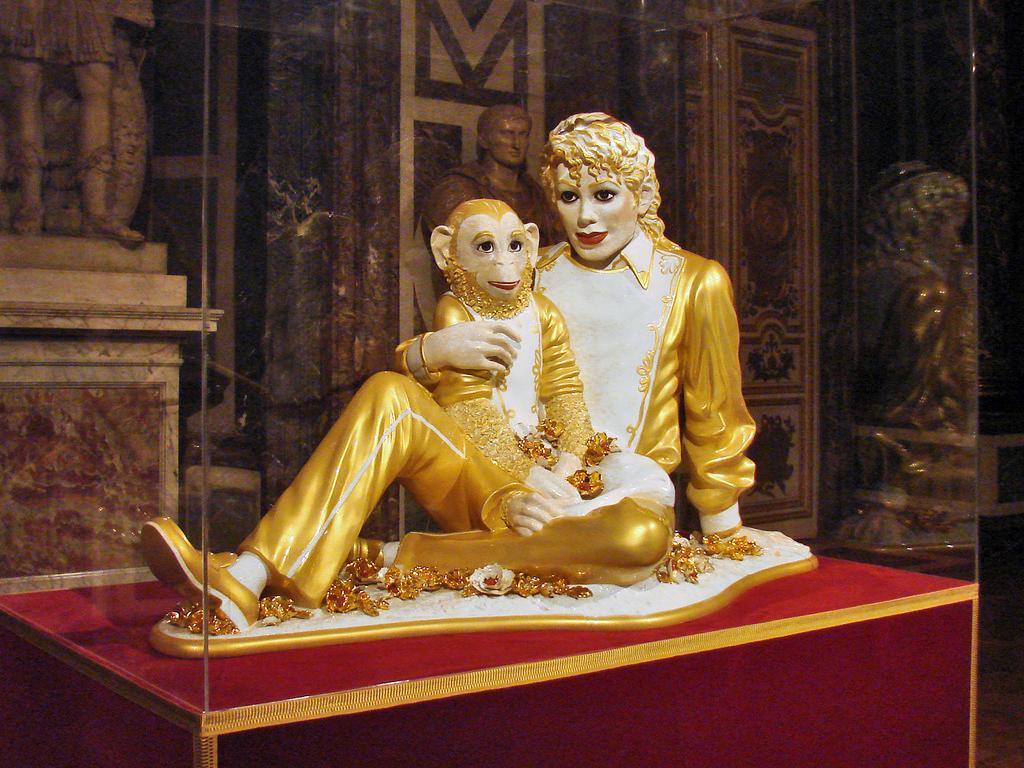Describe this image in one or two sentences. In this image in the front there is an object which is red and golden in colour and on the object there are statues of the animal and there is a statue of the person which are white and golden in colour. In the background there statues and there is a wall. 